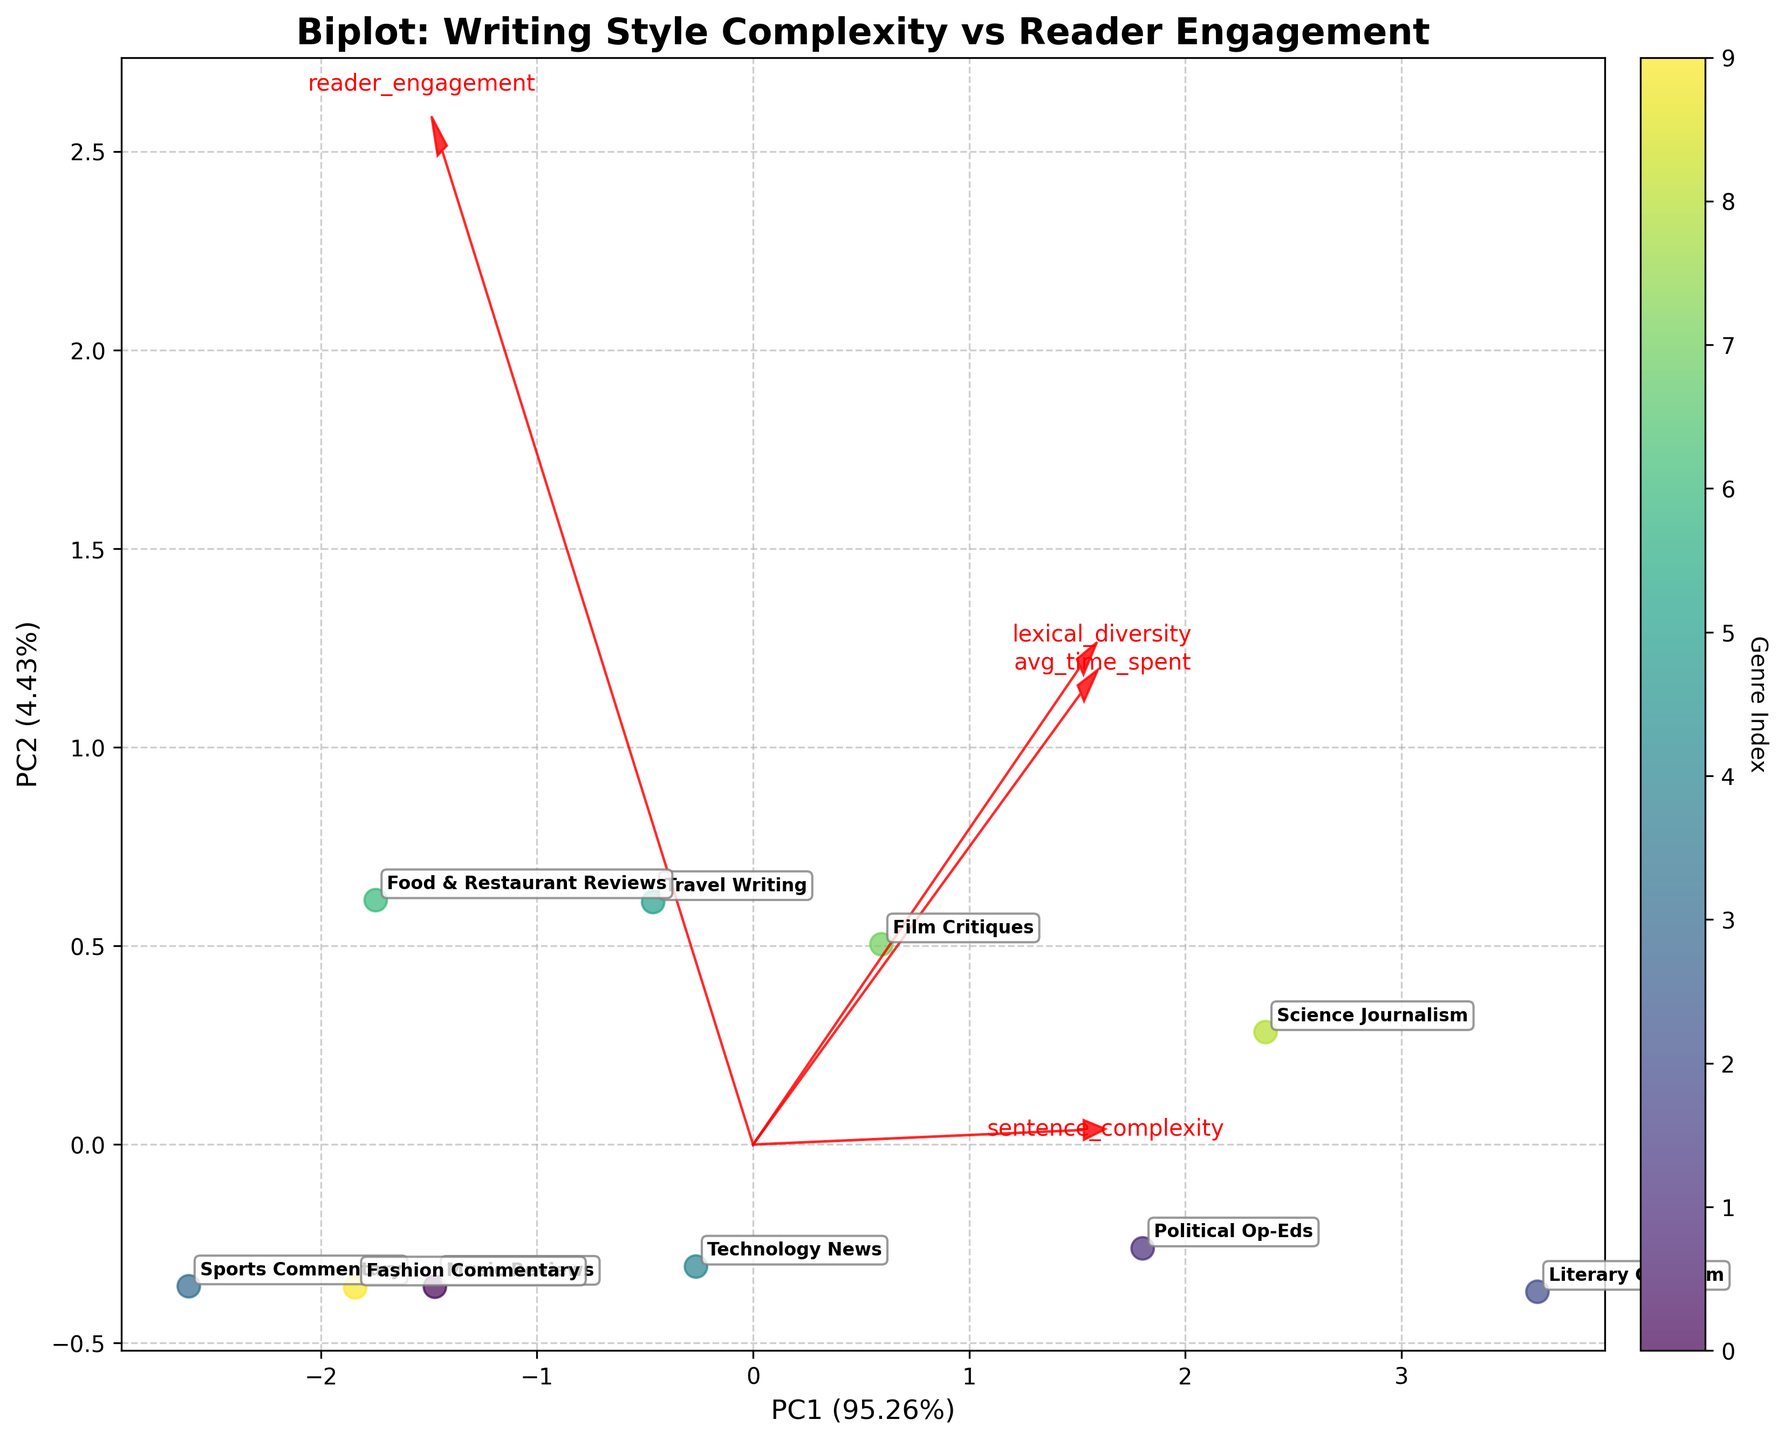what's the title of the plot? The title of a plot is usually clearly displayed at the top of the figure for quick identification. Here, it is centrally located and uses a bold font to draw attention.
Answer: Biplot: Writing Style Complexity vs Reader Engagement how many different genres are represented in the plot? Each data point on the scatter plot represents a different genre. By counting the unique labels annotated on the plot, we determine the total number of genres presented.
Answer: 10 which genre shows the highest contribution on PC1? To find this, we look for the genre placed farthest along the horizontal axis (PC1). The specific genre label at the extreme right or left provides the answer.
Answer: Literary Criticism among the genres, which one has the highest reader engagement? To determine this, we observe the arrows representing the features. The "reader_engagement" arrow points in a direction; we look for the genre closest to the tip of this arrow to find the answer.
Answer: Food & Restaurant Reviews which vector has the smallest influence on PC2? To find the smallest influence on PC2, observe the length of the vectors along the vertical axis. The vector with the shortest vertical projection corresponds to the smallest influence.
Answer: avg_time_spent what's the combined variance explained by PC1 and PC2? The combined variance is the sum of the individual variance percentages explained by PC1 and PC2. These percentages are shown on the x-axis and y-axis labels respectively.
Answer: 78.01% which genres are closest to each other in the biplot? To identify closely positioned genres, examine the scatter plot to find the data points that are geographically nearest to each other, considering annotated genre labels.
Answer: Food & Restaurant Reviews and Fashion Commentary how does sentence complexity correlate with PC1 and PC2? Check the direction and length of the "sentence_complexity" arrow. If it points positively along PC1 or PC2, it suggests a positive correlation with that component, and the length indicates the strength.
Answer: Positively correlated with both which component has the most significant influence on lexical diversity, PC1 or PC2? Observe the "lexical_diversity" arrow to see whether its projection is greater along PC1 or PC2. The longer projection indicates a more significant influence on that component.
Answer: PC2 